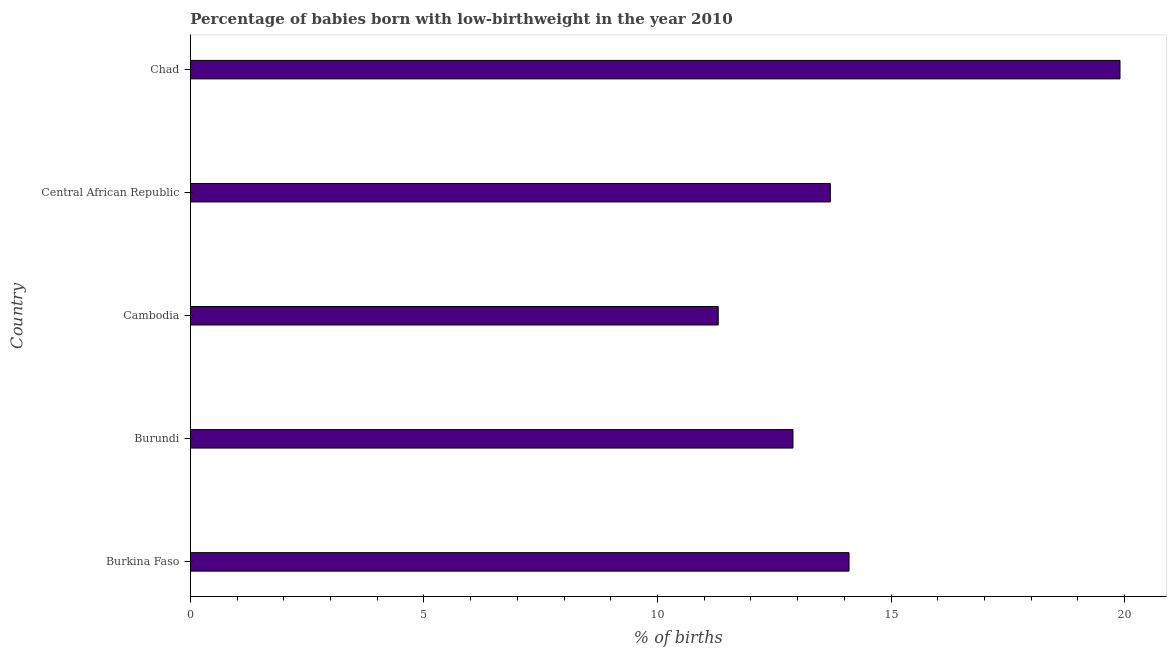Does the graph contain any zero values?
Give a very brief answer. No. What is the title of the graph?
Keep it short and to the point. Percentage of babies born with low-birthweight in the year 2010. What is the label or title of the X-axis?
Ensure brevity in your answer.  % of births. What is the percentage of babies who were born with low-birthweight in Cambodia?
Keep it short and to the point. 11.3. Across all countries, what is the maximum percentage of babies who were born with low-birthweight?
Give a very brief answer. 19.9. In which country was the percentage of babies who were born with low-birthweight maximum?
Offer a very short reply. Chad. In which country was the percentage of babies who were born with low-birthweight minimum?
Your answer should be compact. Cambodia. What is the sum of the percentage of babies who were born with low-birthweight?
Make the answer very short. 71.9. What is the average percentage of babies who were born with low-birthweight per country?
Your response must be concise. 14.38. In how many countries, is the percentage of babies who were born with low-birthweight greater than 5 %?
Ensure brevity in your answer.  5. Is the percentage of babies who were born with low-birthweight in Burundi less than that in Cambodia?
Offer a terse response. No. What is the difference between the highest and the second highest percentage of babies who were born with low-birthweight?
Offer a terse response. 5.8. How many bars are there?
Offer a terse response. 5. Are all the bars in the graph horizontal?
Offer a terse response. Yes. Are the values on the major ticks of X-axis written in scientific E-notation?
Make the answer very short. No. What is the % of births of Burkina Faso?
Provide a short and direct response. 14.1. What is the % of births of Cambodia?
Offer a very short reply. 11.3. What is the % of births of Central African Republic?
Your answer should be compact. 13.7. What is the % of births in Chad?
Your answer should be very brief. 19.9. What is the difference between the % of births in Burkina Faso and Burundi?
Provide a short and direct response. 1.2. What is the difference between the % of births in Burundi and Central African Republic?
Make the answer very short. -0.8. What is the difference between the % of births in Central African Republic and Chad?
Your response must be concise. -6.2. What is the ratio of the % of births in Burkina Faso to that in Burundi?
Offer a very short reply. 1.09. What is the ratio of the % of births in Burkina Faso to that in Cambodia?
Make the answer very short. 1.25. What is the ratio of the % of births in Burkina Faso to that in Chad?
Your response must be concise. 0.71. What is the ratio of the % of births in Burundi to that in Cambodia?
Provide a short and direct response. 1.14. What is the ratio of the % of births in Burundi to that in Central African Republic?
Offer a terse response. 0.94. What is the ratio of the % of births in Burundi to that in Chad?
Ensure brevity in your answer.  0.65. What is the ratio of the % of births in Cambodia to that in Central African Republic?
Give a very brief answer. 0.82. What is the ratio of the % of births in Cambodia to that in Chad?
Your answer should be very brief. 0.57. What is the ratio of the % of births in Central African Republic to that in Chad?
Make the answer very short. 0.69. 